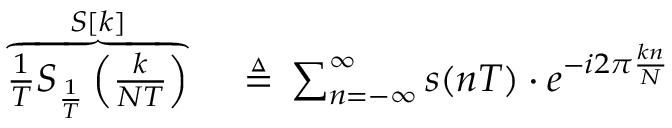<formula> <loc_0><loc_0><loc_500><loc_500>\begin{array} { r l } { \overbrace { { \frac { 1 } { T } } S _ { \frac { 1 } { T } } \left ( { \frac { k } { N T } } \right ) } ^ { S [ k ] } \, } & \triangle q \, \sum _ { n = - \infty } ^ { \infty } s ( n T ) \cdot e ^ { - i 2 \pi { \frac { k n } { N } } } } \end{array}</formula> 